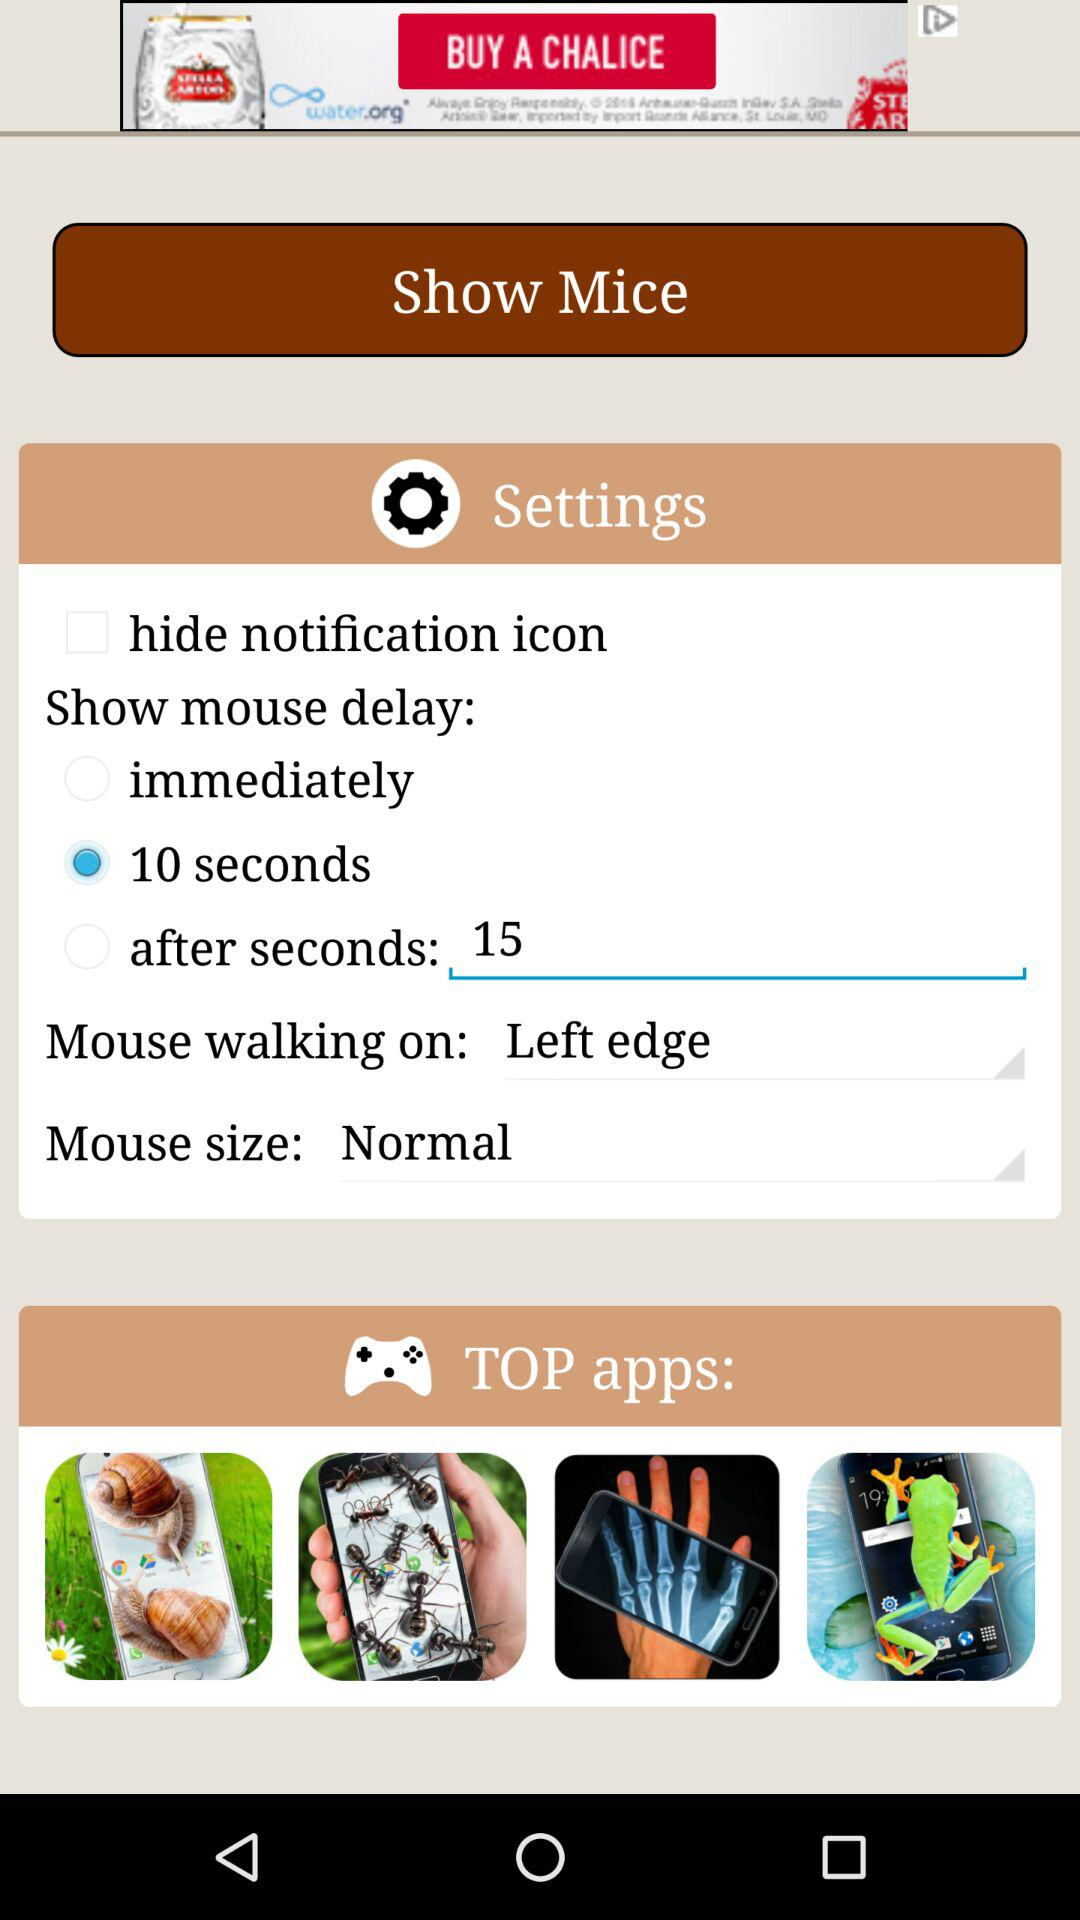What is the mouse size? The mouse size is "Normal". 